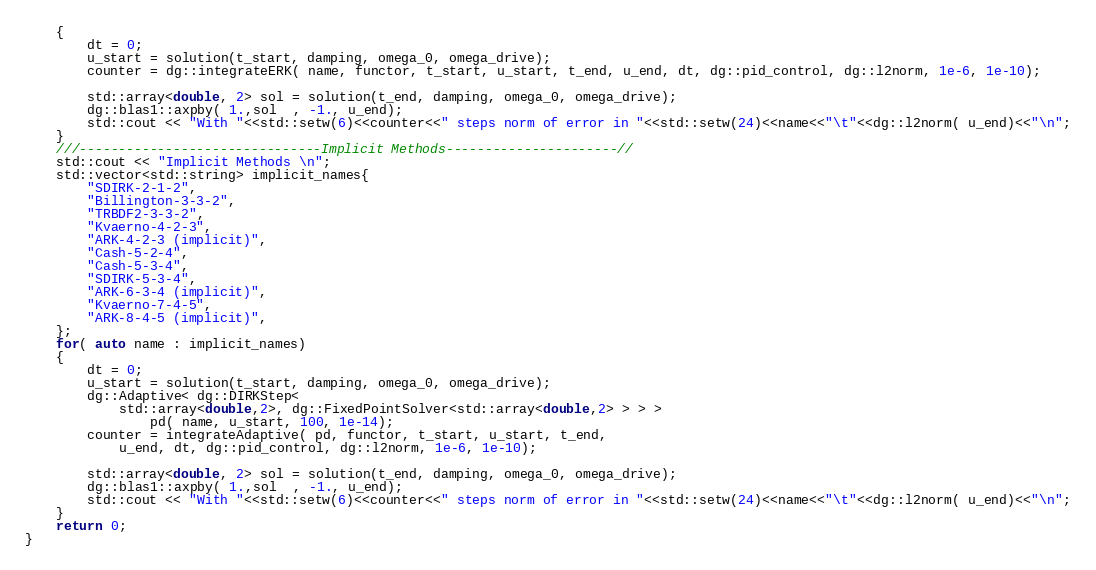<code> <loc_0><loc_0><loc_500><loc_500><_Cuda_>    {
        dt = 0;
        u_start = solution(t_start, damping, omega_0, omega_drive);
        counter = dg::integrateERK( name, functor, t_start, u_start, t_end, u_end, dt, dg::pid_control, dg::l2norm, 1e-6, 1e-10);

        std::array<double, 2> sol = solution(t_end, damping, omega_0, omega_drive);
        dg::blas1::axpby( 1.,sol  , -1., u_end);
        std::cout << "With "<<std::setw(6)<<counter<<" steps norm of error in "<<std::setw(24)<<name<<"\t"<<dg::l2norm( u_end)<<"\n";
    }
    ///-------------------------------Implicit Methods----------------------//
    std::cout << "Implicit Methods \n";
    std::vector<std::string> implicit_names{
        "SDIRK-2-1-2",
        "Billington-3-3-2",
        "TRBDF2-3-3-2",
        "Kvaerno-4-2-3",
        "ARK-4-2-3 (implicit)",
        "Cash-5-2-4",
        "Cash-5-3-4",
        "SDIRK-5-3-4",
        "ARK-6-3-4 (implicit)",
        "Kvaerno-7-4-5",
        "ARK-8-4-5 (implicit)",
    };
    for( auto name : implicit_names)
    {
        dt = 0;
        u_start = solution(t_start, damping, omega_0, omega_drive);
        dg::Adaptive< dg::DIRKStep<
            std::array<double,2>, dg::FixedPointSolver<std::array<double,2> > > >
                pd( name, u_start, 100, 1e-14);
        counter = integrateAdaptive( pd, functor, t_start, u_start, t_end,
            u_end, dt, dg::pid_control, dg::l2norm, 1e-6, 1e-10);

        std::array<double, 2> sol = solution(t_end, damping, omega_0, omega_drive);
        dg::blas1::axpby( 1.,sol  , -1., u_end);
        std::cout << "With "<<std::setw(6)<<counter<<" steps norm of error in "<<std::setw(24)<<name<<"\t"<<dg::l2norm( u_end)<<"\n";
    }
    return 0;
}
</code> 